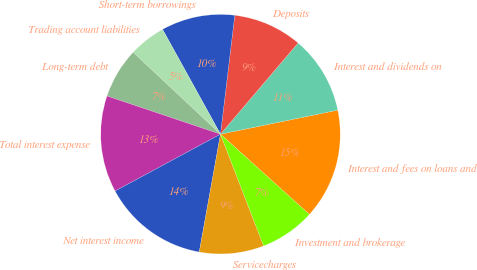Convert chart to OTSL. <chart><loc_0><loc_0><loc_500><loc_500><pie_chart><fcel>Interest and fees on loans and<fcel>Interest and dividends on<fcel>Deposits<fcel>Short-term borrowings<fcel>Trading account liabilities<fcel>Long-term debt<fcel>Total interest expense<fcel>Net interest income<fcel>Servicecharges<fcel>Investment and brokerage<nl><fcel>14.91%<fcel>10.56%<fcel>9.32%<fcel>9.94%<fcel>4.97%<fcel>6.83%<fcel>13.04%<fcel>14.29%<fcel>8.7%<fcel>7.45%<nl></chart> 